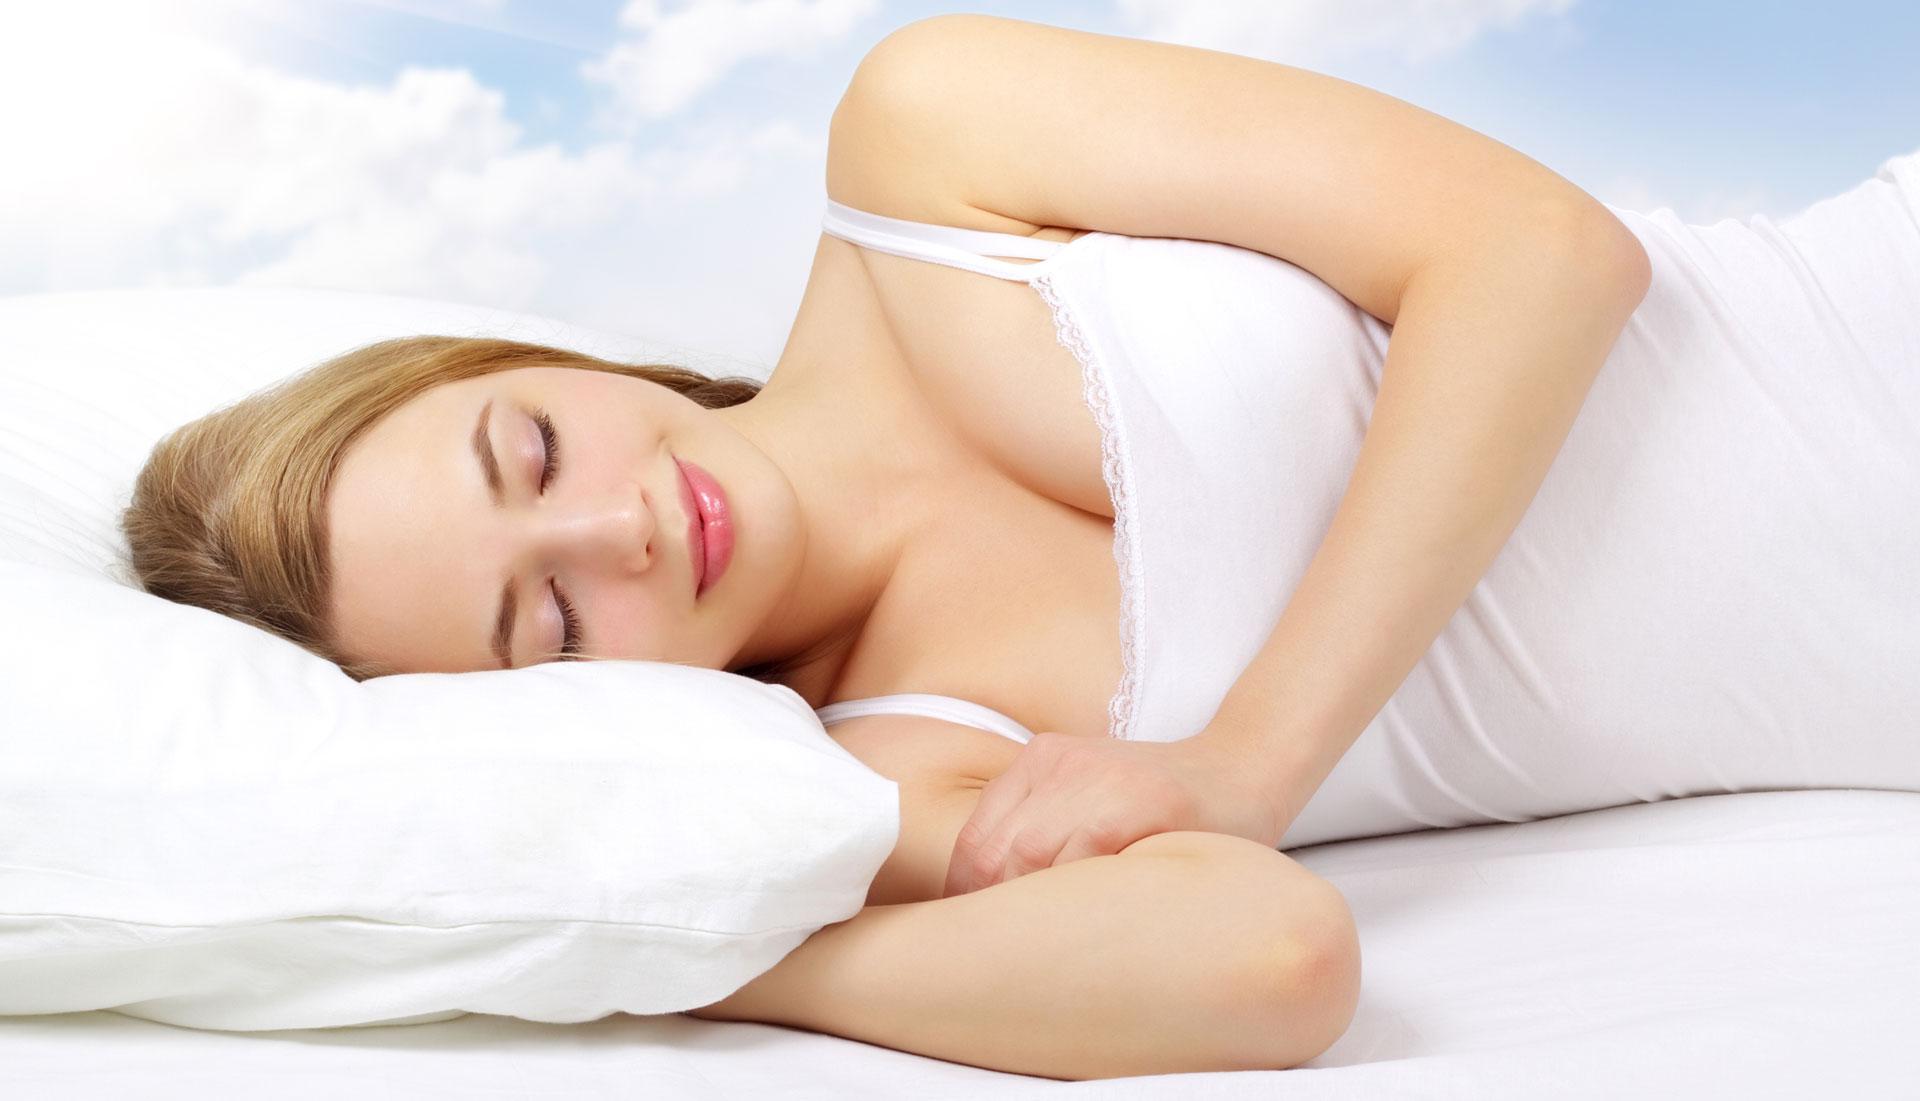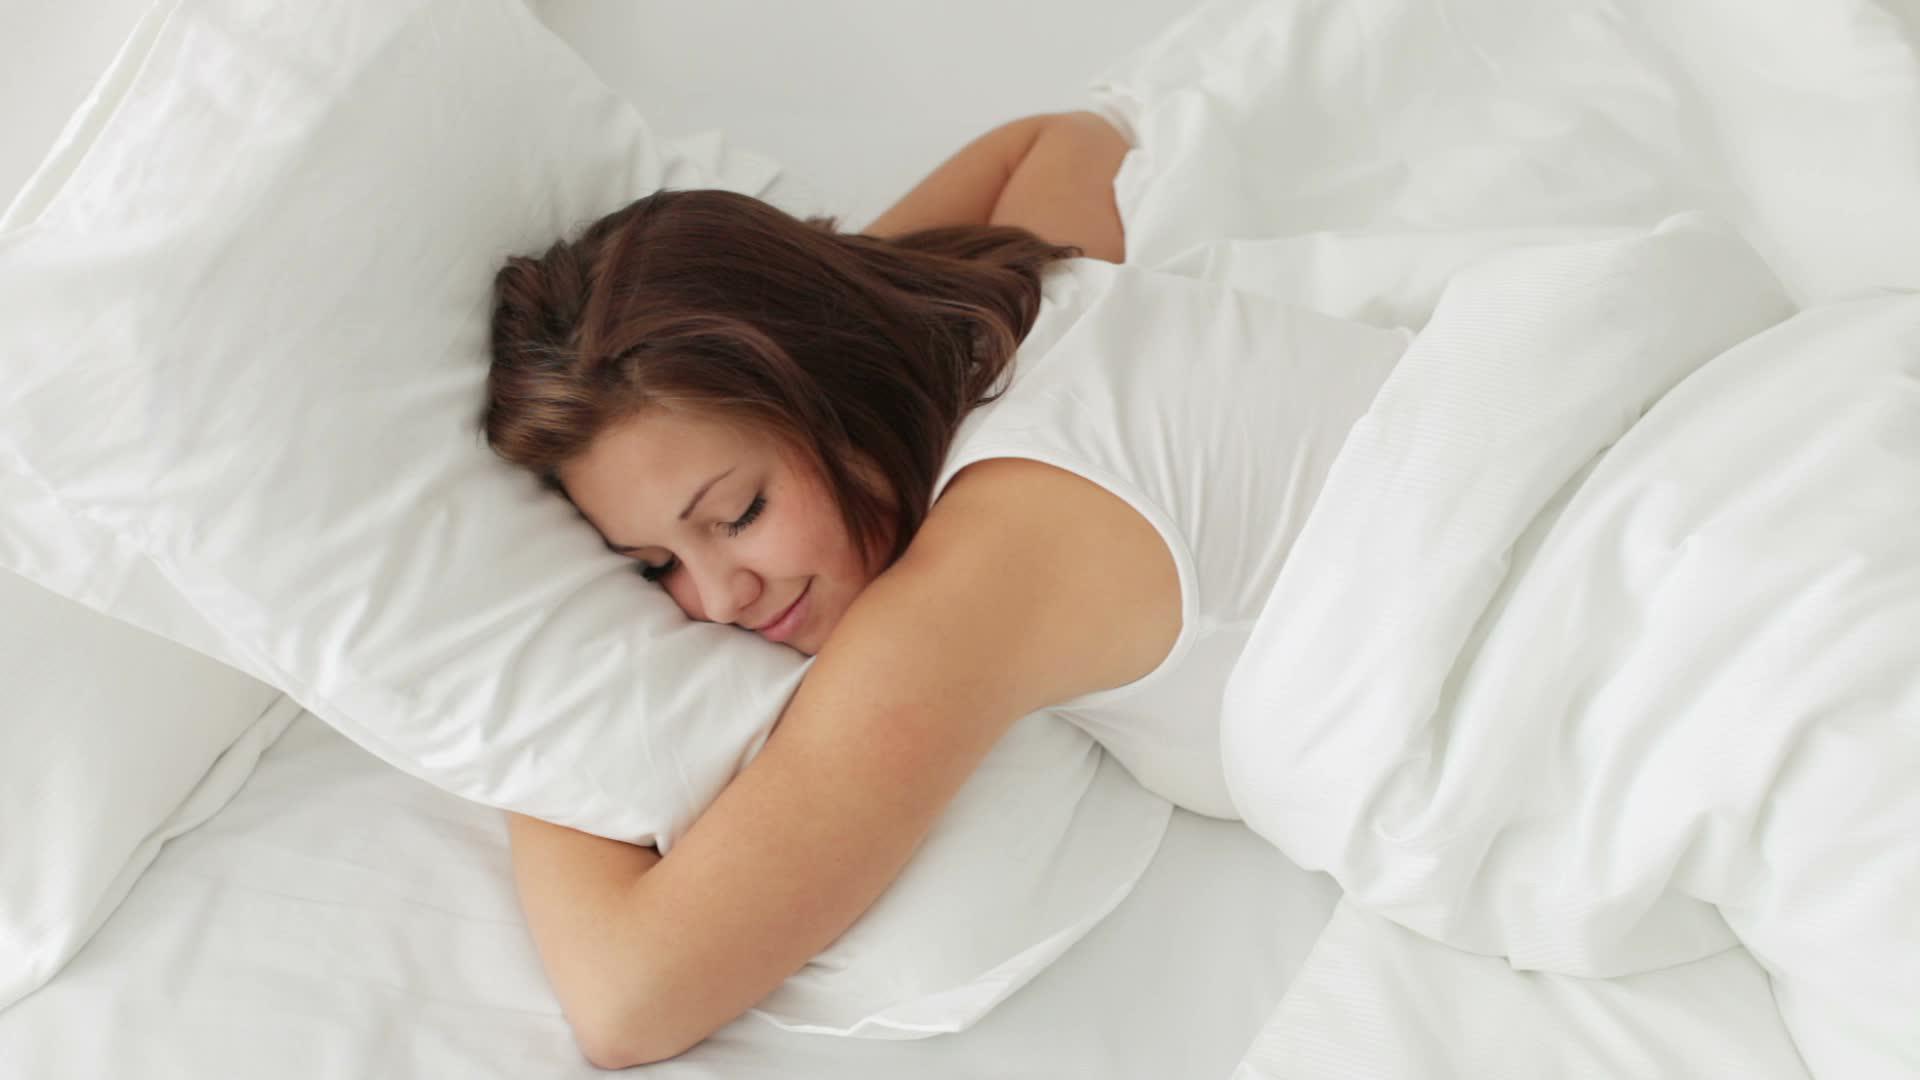The first image is the image on the left, the second image is the image on the right. For the images displayed, is the sentence "A single person is sleeping on a pillow in each of the images." factually correct? Answer yes or no. Yes. The first image is the image on the left, the second image is the image on the right. Examine the images to the left and right. Is the description "Each image shows only an adult female sleeper, and at least one image shows a side-sleeper." accurate? Answer yes or no. Yes. 